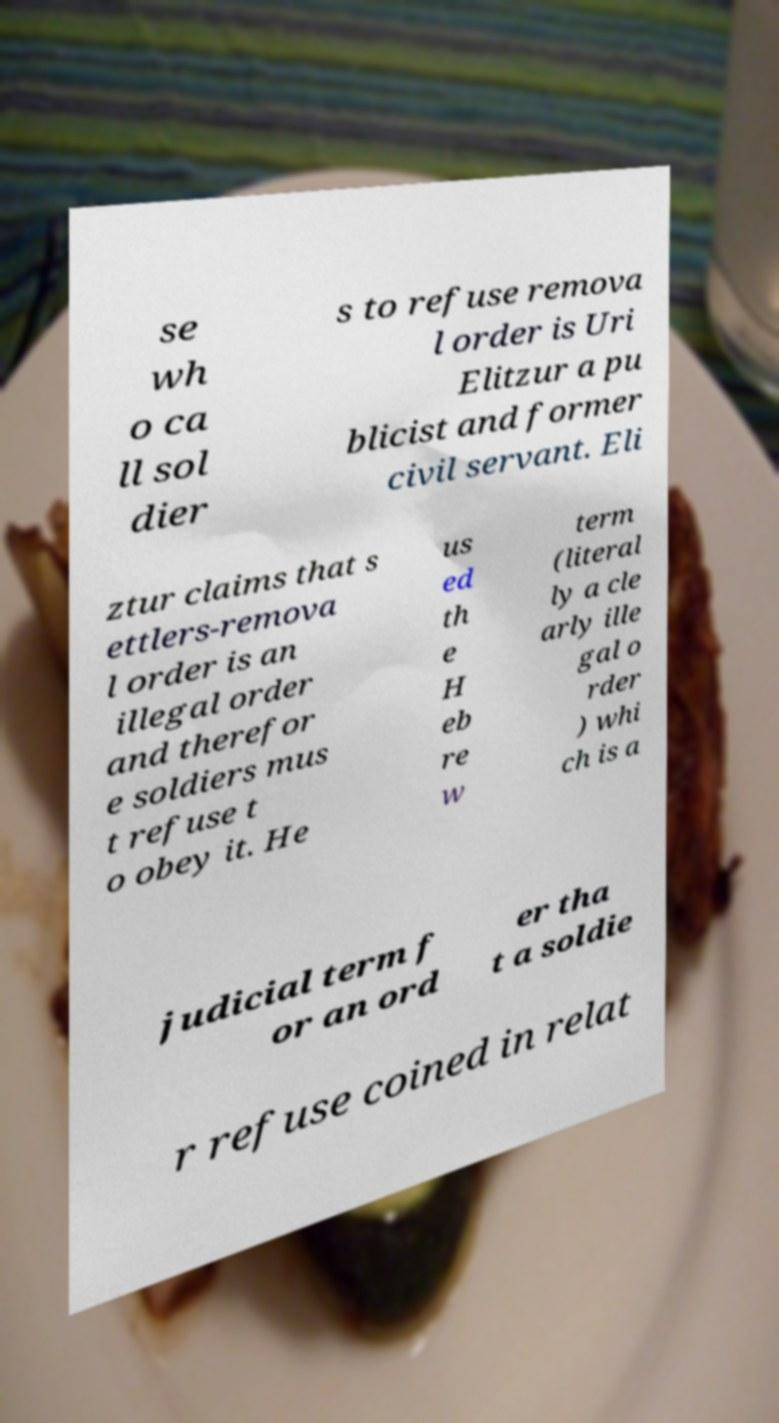Can you accurately transcribe the text from the provided image for me? se wh o ca ll sol dier s to refuse remova l order is Uri Elitzur a pu blicist and former civil servant. Eli ztur claims that s ettlers-remova l order is an illegal order and therefor e soldiers mus t refuse t o obey it. He us ed th e H eb re w term (literal ly a cle arly ille gal o rder ) whi ch is a judicial term f or an ord er tha t a soldie r refuse coined in relat 